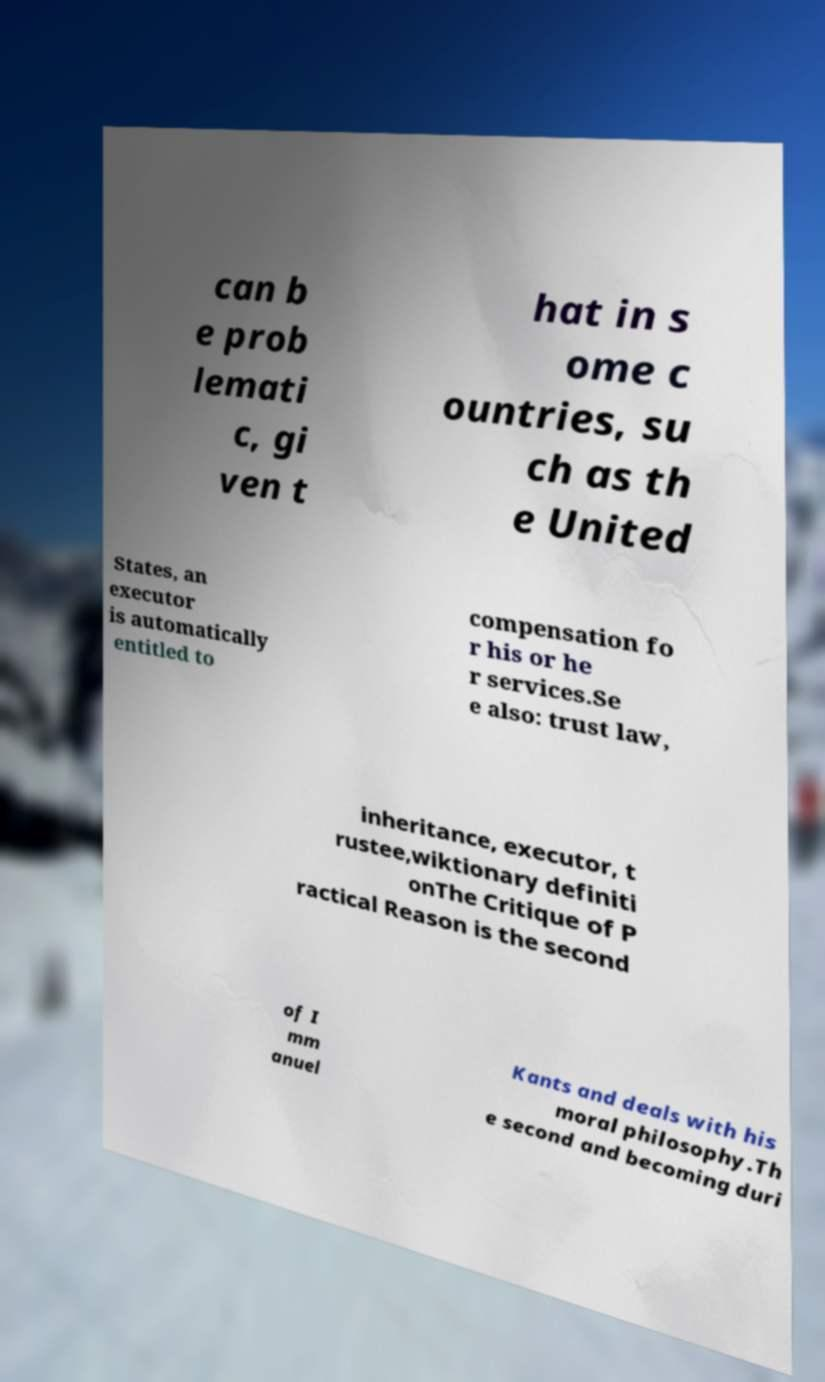For documentation purposes, I need the text within this image transcribed. Could you provide that? can b e prob lemati c, gi ven t hat in s ome c ountries, su ch as th e United States, an executor is automatically entitled to compensation fo r his or he r services.Se e also: trust law, inheritance, executor, t rustee,wiktionary definiti onThe Critique of P ractical Reason is the second of I mm anuel Kants and deals with his moral philosophy.Th e second and becoming duri 